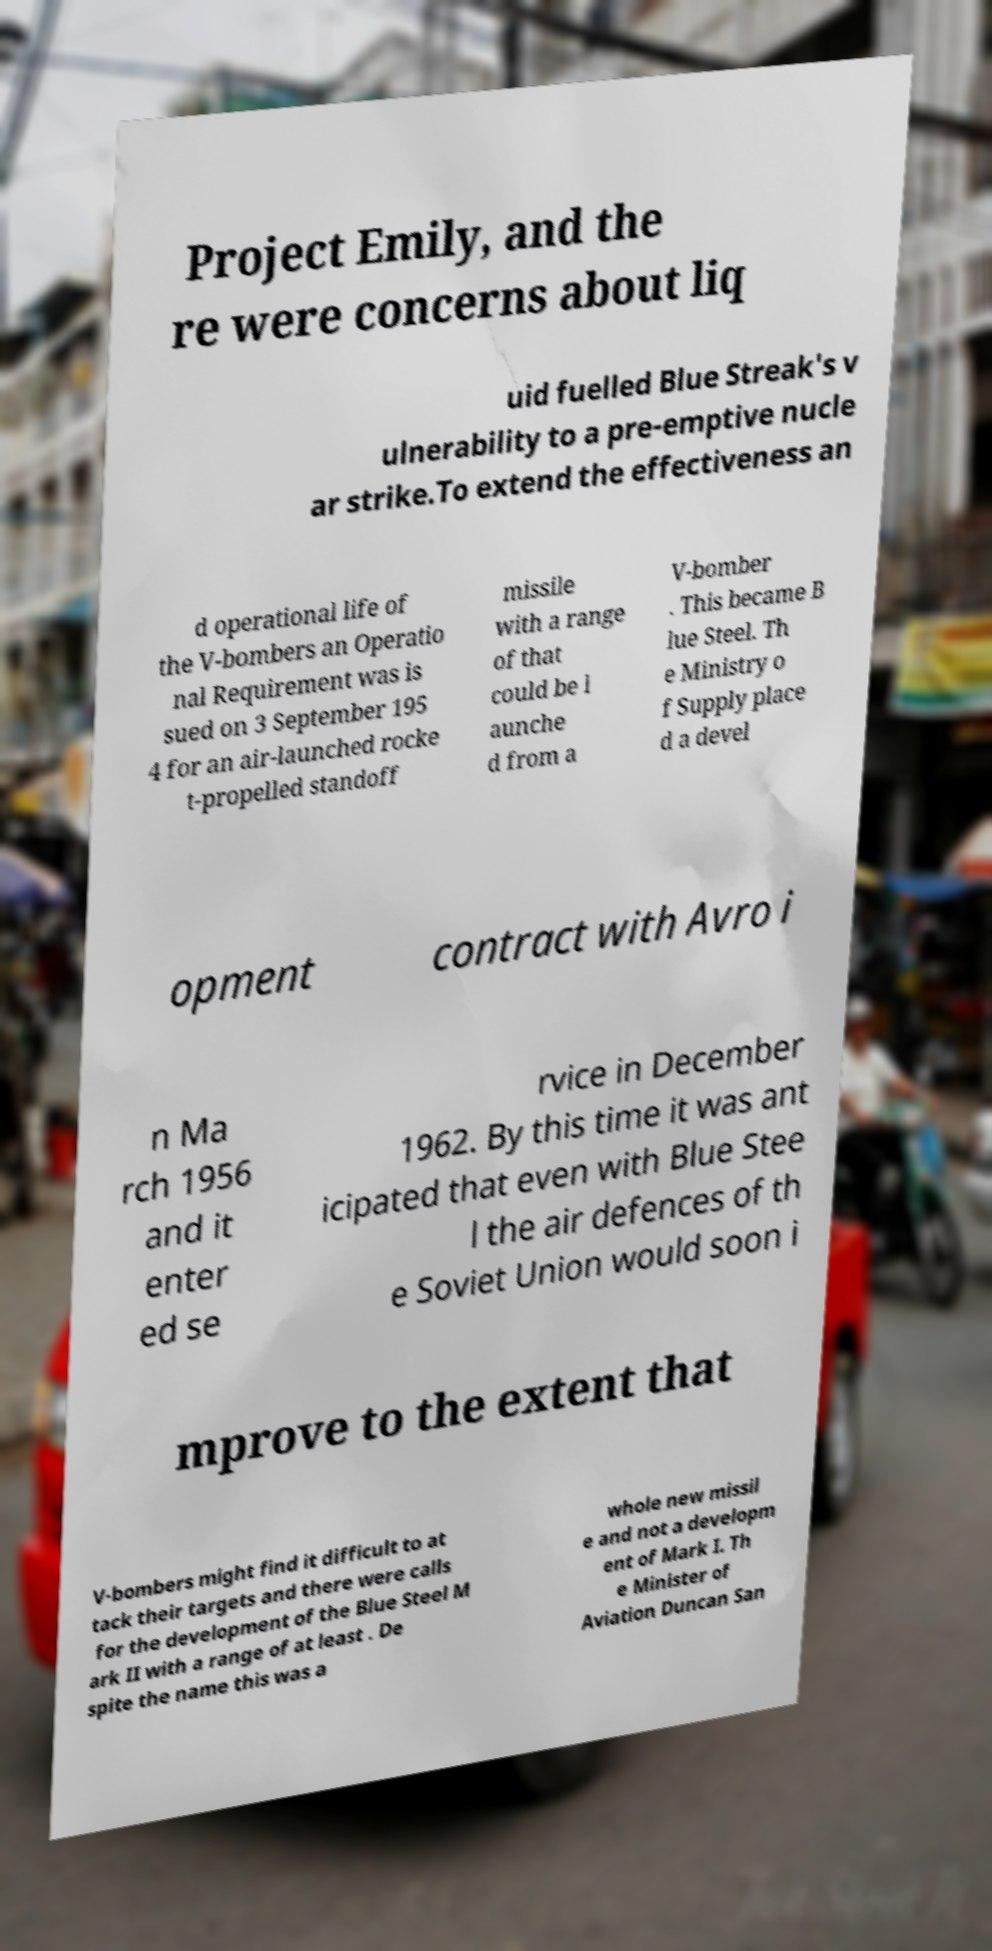Could you extract and type out the text from this image? Project Emily, and the re were concerns about liq uid fuelled Blue Streak's v ulnerability to a pre-emptive nucle ar strike.To extend the effectiveness an d operational life of the V-bombers an Operatio nal Requirement was is sued on 3 September 195 4 for an air-launched rocke t-propelled standoff missile with a range of that could be l aunche d from a V-bomber . This became B lue Steel. Th e Ministry o f Supply place d a devel opment contract with Avro i n Ma rch 1956 and it enter ed se rvice in December 1962. By this time it was ant icipated that even with Blue Stee l the air defences of th e Soviet Union would soon i mprove to the extent that V-bombers might find it difficult to at tack their targets and there were calls for the development of the Blue Steel M ark II with a range of at least . De spite the name this was a whole new missil e and not a developm ent of Mark I. Th e Minister of Aviation Duncan San 